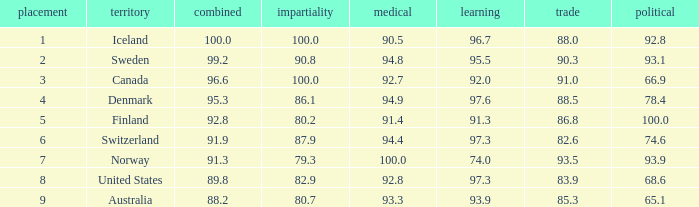What's the economics score with education being 92.0 91.0. 